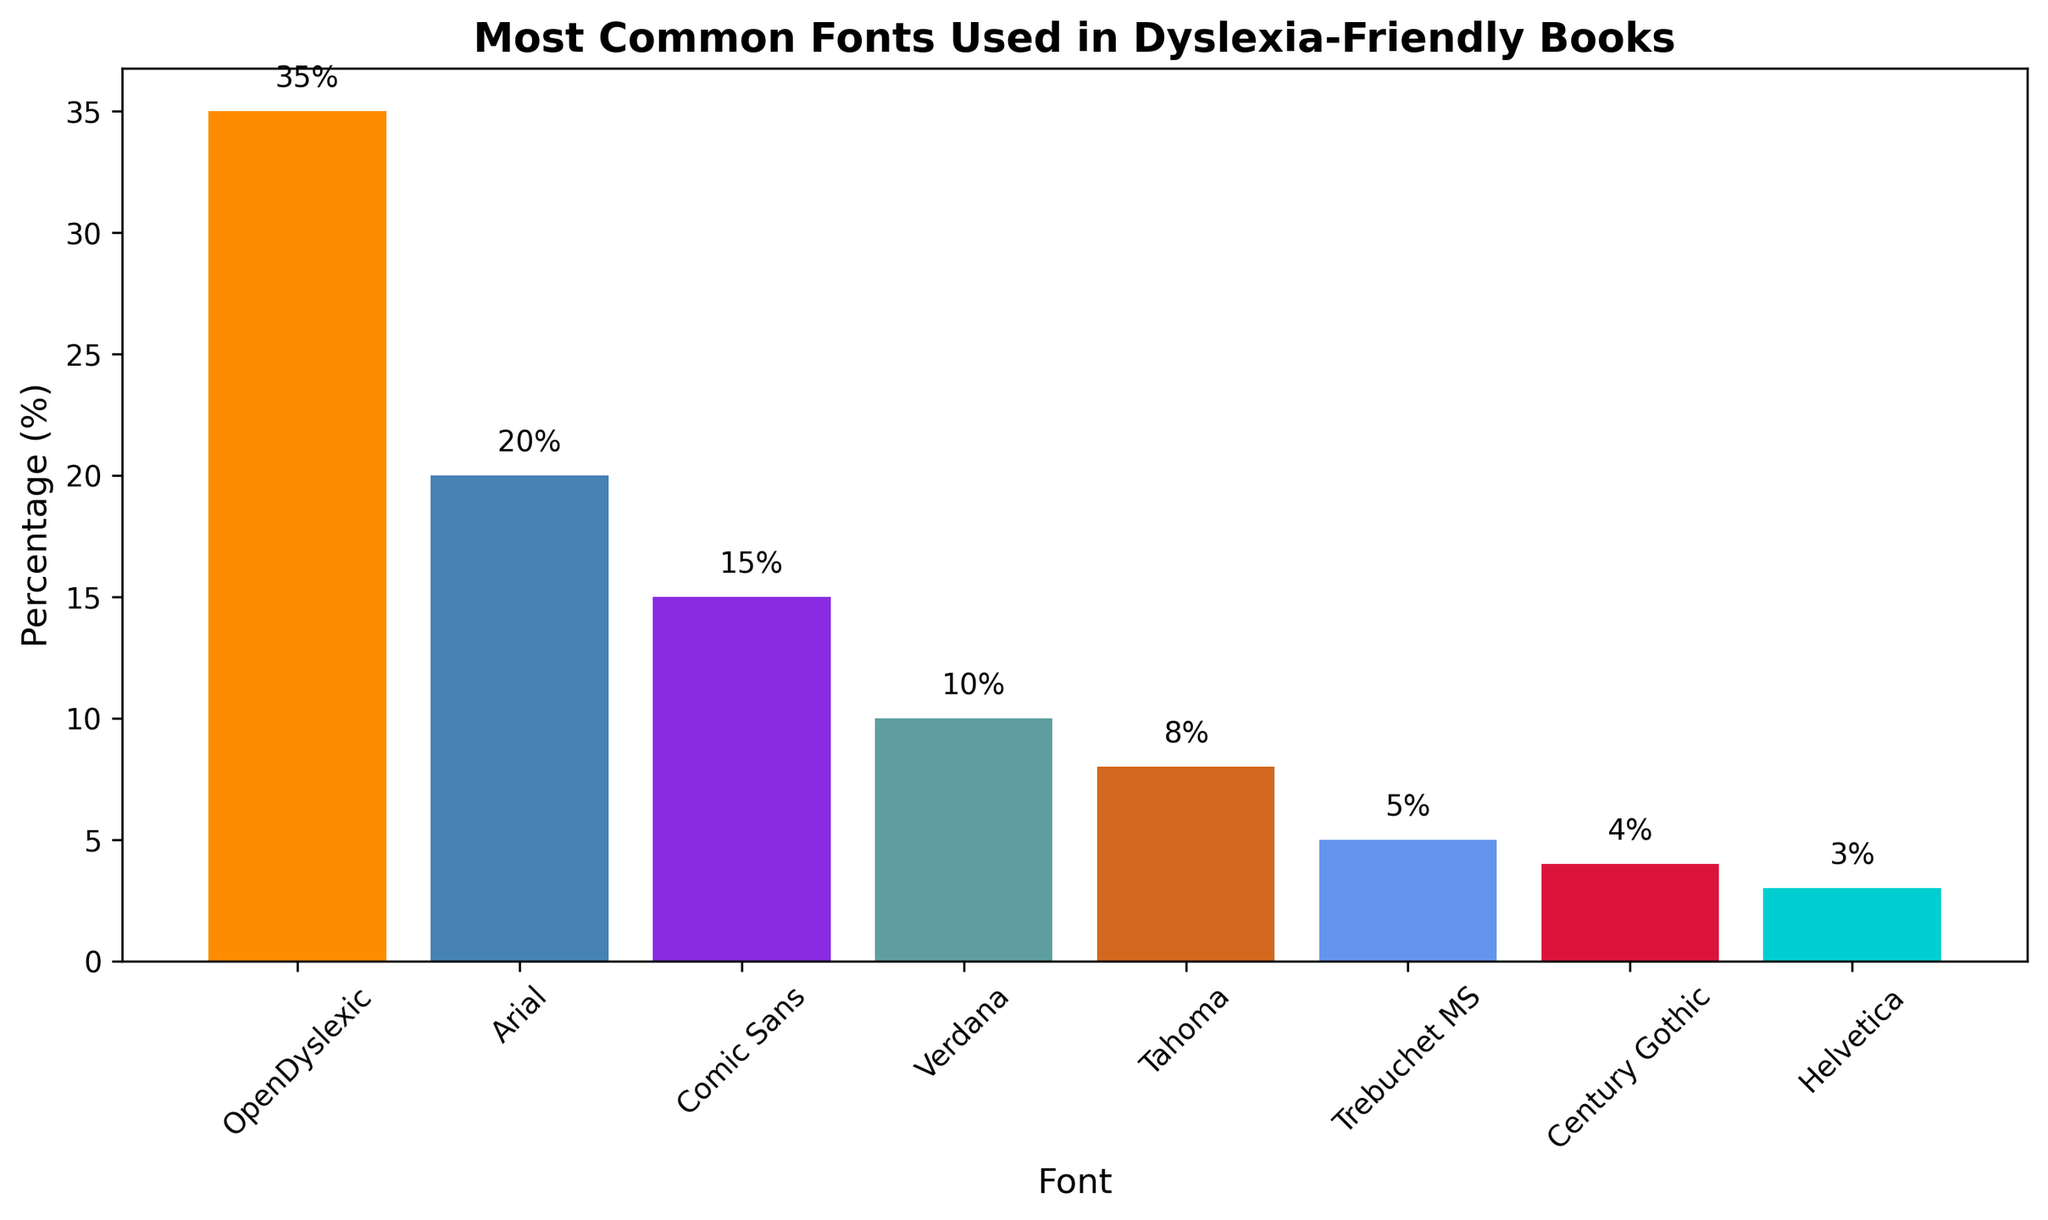What is the most common font used in dyslexia-friendly books? By looking at the bar chart, the tallest bar represents the font that is most commonly used. This font's label is "OpenDyslexic".
Answer: OpenDyslexic What is the difference in percentage between the most and least common fonts? The most common font, OpenDyslexic, has a percentage of 35%, while the least common font, Helvetica, has a percentage of 3%. The difference is 35% - 3% = 32%.
Answer: 32% Which font has a higher percentage, Arial or Comic Sans? By comparing the heights of the bars for Arial and Comic Sans, Arial has a taller bar representing 20%, while Comic Sans represents 15%. Therefore, Arial has a higher percentage.
Answer: Arial How many fonts have a percentage greater than 10%? By observing the bars, the fonts with percentages greater than 10% are OpenDyslexic, Arial, Comic Sans, and Verdana. This makes a total of 4 fonts.
Answer: 4 What is the combined percentage of Tahoma and Trebuchet MS? The percentage for Tahoma is 8%, and for Trebuchet MS, it is 5%. Adding them together: 8% + 5% = 13%.
Answer: 13% Which font has the shortest bar, and what is its percentage? The shortest bar in the bar chart is for Helvetica, and its percentage is 3%.
Answer: Helvetica, 3% If you were to recommend fonts with a percentage above the average, which ones would you recommend? First, calculate the average percentage. The total percentage is 100% (as percentages sum to 100), and there are 8 fonts. So, the average is 100% / 8 = 12.5%. The fonts above this average are OpenDyslexic (35%), Arial (20%), Comic Sans (15%), and Verdana (10%). Thus, recommend OpenDyslexic, Arial, and Comic Sans.
Answer: OpenDyslexic, Arial, Comic Sans By how much does the percentage of Verdana exceed that of Century Gothic? Verdana has a percentage of 10%, and Century Gothic has a percentage of 4%. The difference is 10% - 4% = 6%.
Answer: 6% Which two fonts combined have a percentage approximately equal to the percentage of OpenDyslexic? OpenDyslexic has a percentage of 35%. Combining Arial (20%) and Comic Sans (15%) gives 20% + 15% = 35%, which equals the percentage of OpenDyslexic.
Answer: Arial and Comic Sans What is the combined percentage of all fonts with a percentage less than 5%? The fonts under 5% are Century Gothic (4%) and Helvetica (3%). Combining them gives 4% + 3% = 7%.
Answer: 7% 